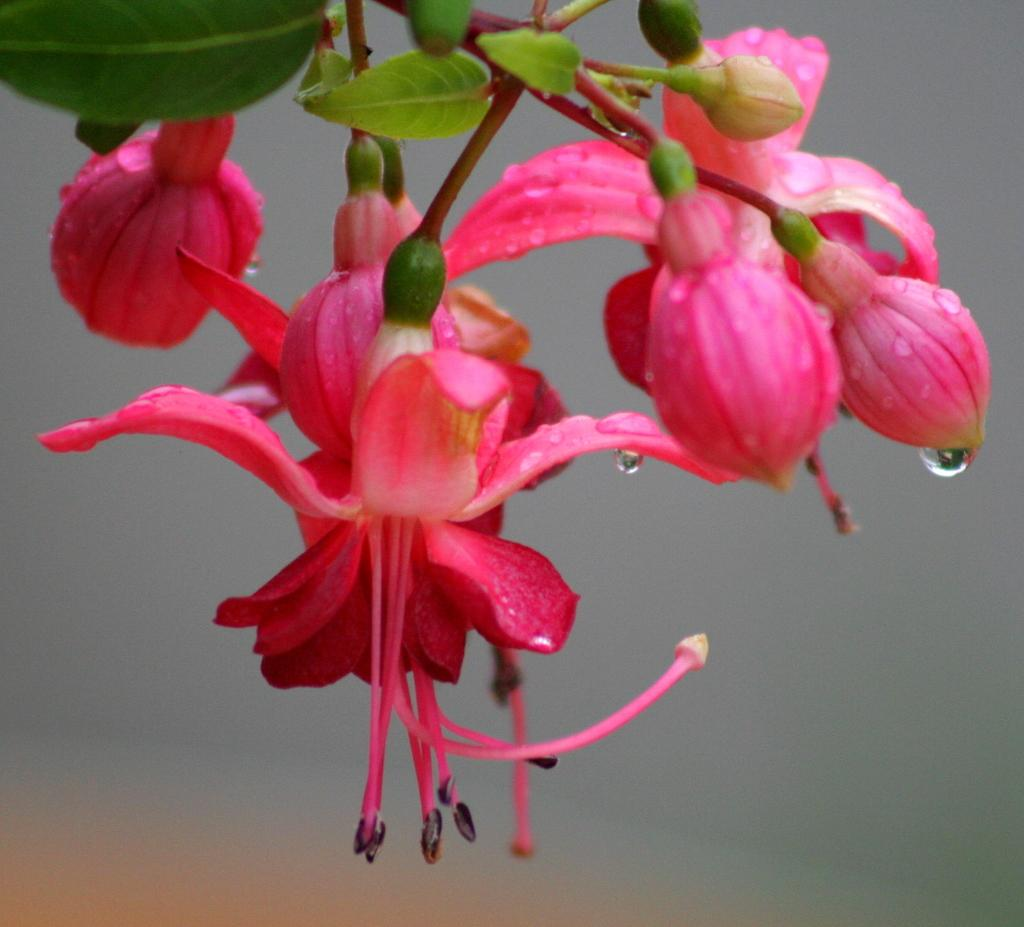What type of plants can be seen in the image? There are flowers in the image. What color are the flowers? The flowers are pink in color. What else can be seen in the image besides the flowers? There are leaves in the image. What color are the leaves? The leaves are green in color. How would you describe the background of the image? The background of the image is blurred. What type of wood is used to make the tub in the image? There is no tub present in the image; it features flowers and leaves with a blurred background. Can you describe the argument taking place between the flowers in the image? There is no argument depicted in the image; it simply shows flowers and leaves with a blurred background. 